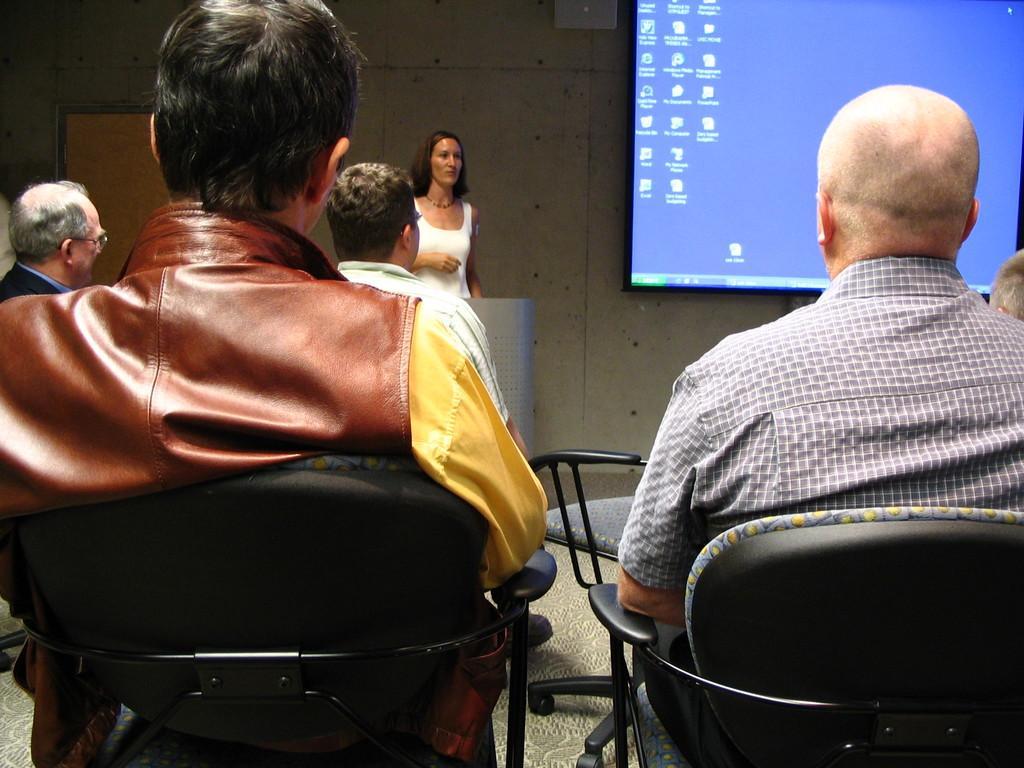Please provide a concise description of this image. This picture is clicked in the conference room. Here, we see four men are sitting on the chairs. The girl in the white T-shirt is standing beside the white wall. She is trying to explain something. In the right top of the picture, we see a projector screen. 